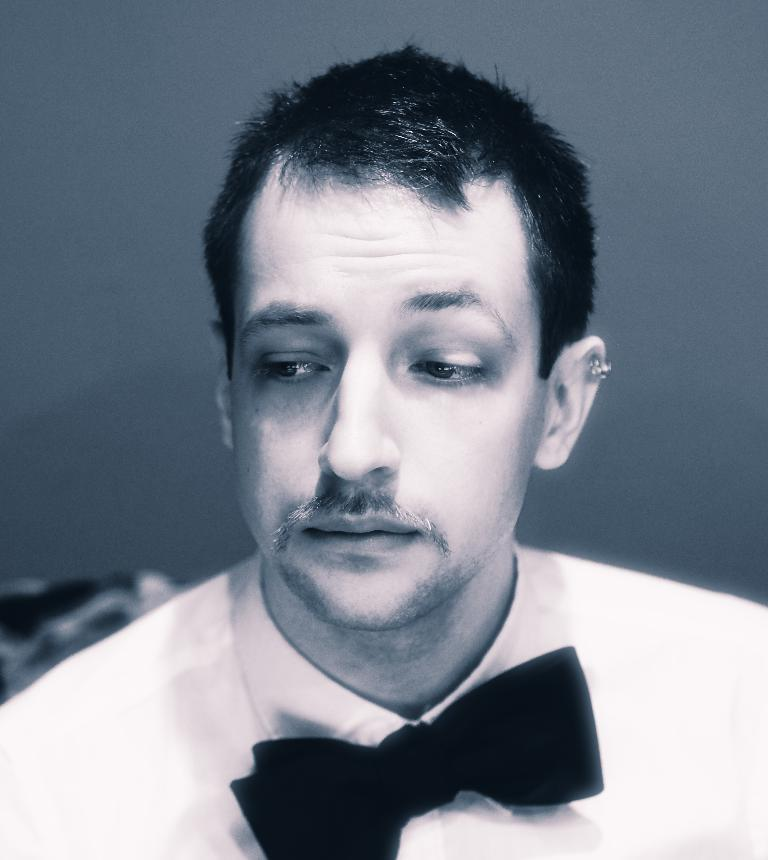What type of image is present in the picture? The image contains a black and white picture. Can you describe the subject of the black and white picture? The picture is of a person. What type of tub is visible in the image? There is no tub present in the image. What type of competition is the person participating in within the image? The image does not depict any competition; it is a black and white picture of a person. What title does the person hold in the image? The image does not provide any information about the person's title or role. 